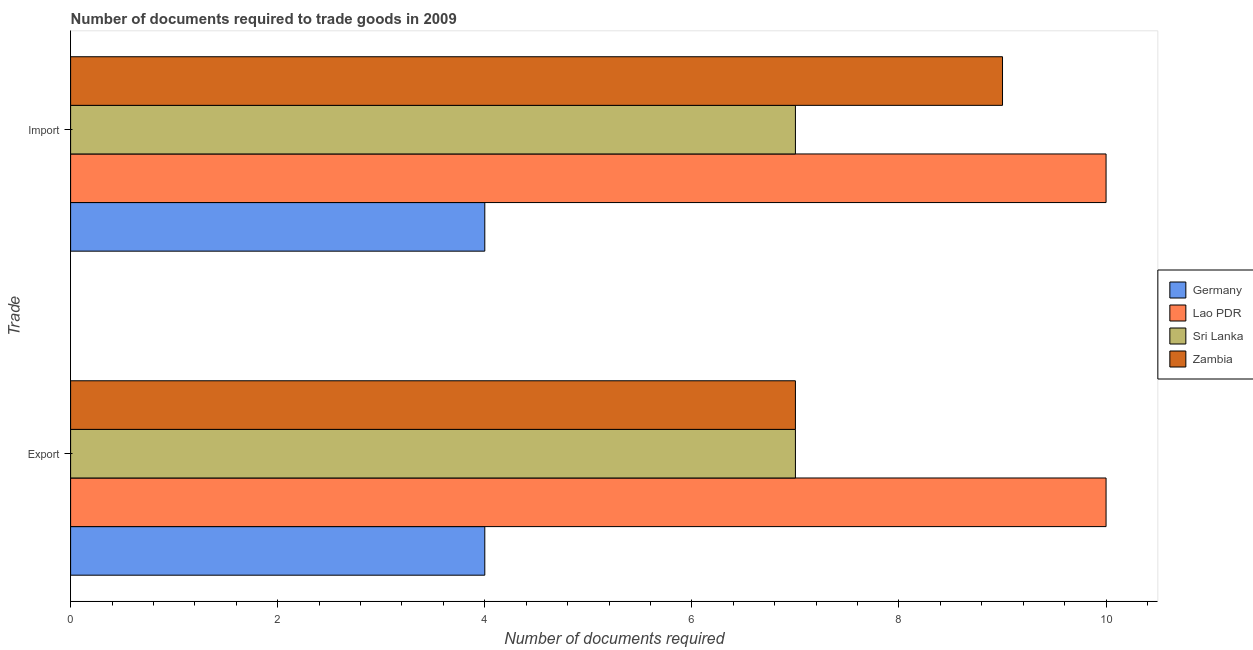How many different coloured bars are there?
Keep it short and to the point. 4. What is the label of the 1st group of bars from the top?
Ensure brevity in your answer.  Import. What is the number of documents required to import goods in Zambia?
Ensure brevity in your answer.  9. Across all countries, what is the maximum number of documents required to export goods?
Offer a terse response. 10. Across all countries, what is the minimum number of documents required to import goods?
Your answer should be very brief. 4. In which country was the number of documents required to export goods maximum?
Offer a very short reply. Lao PDR. In which country was the number of documents required to export goods minimum?
Provide a succinct answer. Germany. What is the total number of documents required to export goods in the graph?
Provide a succinct answer. 28. What is the difference between the number of documents required to import goods in Zambia and that in Lao PDR?
Give a very brief answer. -1. What is the difference between the number of documents required to export goods in Sri Lanka and the number of documents required to import goods in Lao PDR?
Offer a terse response. -3. In how many countries, is the number of documents required to export goods greater than 1.6 ?
Keep it short and to the point. 4. What is the difference between two consecutive major ticks on the X-axis?
Give a very brief answer. 2. Does the graph contain grids?
Keep it short and to the point. No. Where does the legend appear in the graph?
Offer a terse response. Center right. What is the title of the graph?
Provide a short and direct response. Number of documents required to trade goods in 2009. Does "Zambia" appear as one of the legend labels in the graph?
Your answer should be very brief. Yes. What is the label or title of the X-axis?
Provide a succinct answer. Number of documents required. What is the label or title of the Y-axis?
Your answer should be very brief. Trade. What is the Number of documents required of Lao PDR in Export?
Your answer should be very brief. 10. What is the Number of documents required in Zambia in Export?
Make the answer very short. 7. What is the Number of documents required in Lao PDR in Import?
Make the answer very short. 10. What is the Number of documents required of Zambia in Import?
Provide a succinct answer. 9. Across all Trade, what is the maximum Number of documents required in Germany?
Give a very brief answer. 4. Across all Trade, what is the maximum Number of documents required in Sri Lanka?
Make the answer very short. 7. Across all Trade, what is the maximum Number of documents required of Zambia?
Provide a short and direct response. 9. Across all Trade, what is the minimum Number of documents required of Lao PDR?
Offer a terse response. 10. Across all Trade, what is the minimum Number of documents required in Zambia?
Offer a terse response. 7. What is the total Number of documents required in Germany in the graph?
Your answer should be compact. 8. What is the difference between the Number of documents required of Lao PDR in Export and that in Import?
Your answer should be very brief. 0. What is the difference between the Number of documents required of Zambia in Export and that in Import?
Your answer should be very brief. -2. What is the difference between the Number of documents required in Germany in Export and the Number of documents required in Lao PDR in Import?
Offer a very short reply. -6. What is the difference between the Number of documents required of Germany in Export and the Number of documents required of Zambia in Import?
Your answer should be compact. -5. What is the average Number of documents required of Sri Lanka per Trade?
Your answer should be very brief. 7. What is the difference between the Number of documents required in Germany and Number of documents required in Zambia in Export?
Your answer should be very brief. -3. What is the difference between the Number of documents required in Lao PDR and Number of documents required in Zambia in Export?
Your response must be concise. 3. What is the difference between the Number of documents required in Lao PDR and Number of documents required in Sri Lanka in Import?
Offer a terse response. 3. What is the difference between the Number of documents required of Lao PDR and Number of documents required of Zambia in Import?
Ensure brevity in your answer.  1. What is the difference between the highest and the second highest Number of documents required in Sri Lanka?
Offer a very short reply. 0. What is the difference between the highest and the second highest Number of documents required of Zambia?
Give a very brief answer. 2. What is the difference between the highest and the lowest Number of documents required of Germany?
Offer a terse response. 0. What is the difference between the highest and the lowest Number of documents required in Lao PDR?
Your answer should be very brief. 0. What is the difference between the highest and the lowest Number of documents required in Sri Lanka?
Ensure brevity in your answer.  0. What is the difference between the highest and the lowest Number of documents required of Zambia?
Your answer should be very brief. 2. 